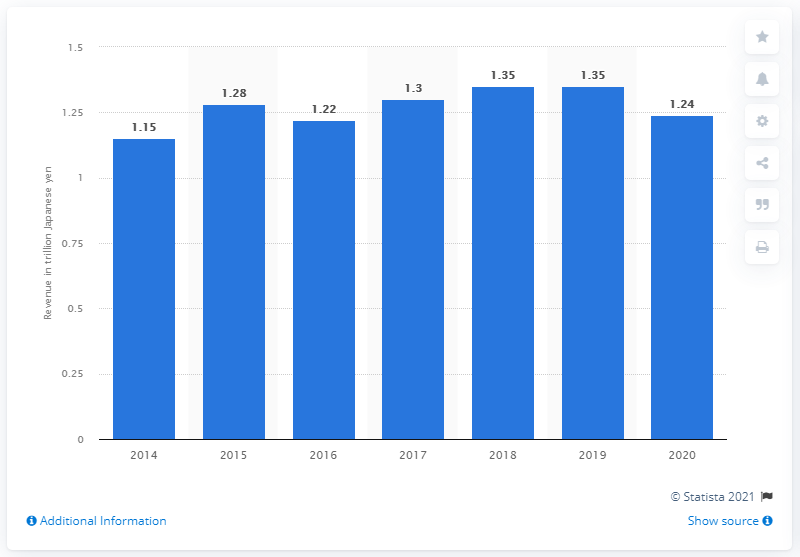Indicate a few pertinent items in this graphic. Takenaka Corporation's total revenue in yen in 2020 was 1,240,000,000. 